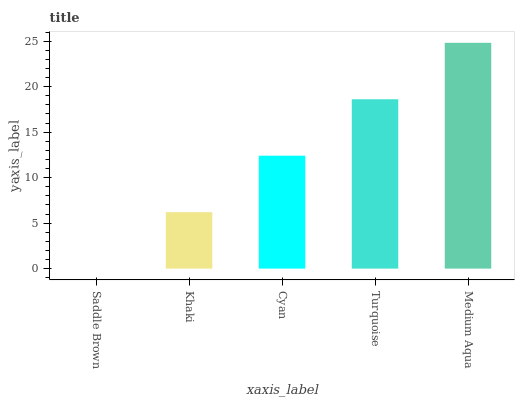Is Saddle Brown the minimum?
Answer yes or no. Yes. Is Medium Aqua the maximum?
Answer yes or no. Yes. Is Khaki the minimum?
Answer yes or no. No. Is Khaki the maximum?
Answer yes or no. No. Is Khaki greater than Saddle Brown?
Answer yes or no. Yes. Is Saddle Brown less than Khaki?
Answer yes or no. Yes. Is Saddle Brown greater than Khaki?
Answer yes or no. No. Is Khaki less than Saddle Brown?
Answer yes or no. No. Is Cyan the high median?
Answer yes or no. Yes. Is Cyan the low median?
Answer yes or no. Yes. Is Saddle Brown the high median?
Answer yes or no. No. Is Medium Aqua the low median?
Answer yes or no. No. 